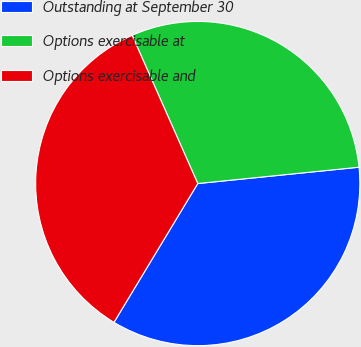Convert chart to OTSL. <chart><loc_0><loc_0><loc_500><loc_500><pie_chart><fcel>Outstanding at September 30<fcel>Options exercisable at<fcel>Options exercisable and<nl><fcel>35.25%<fcel>30.03%<fcel>34.72%<nl></chart> 